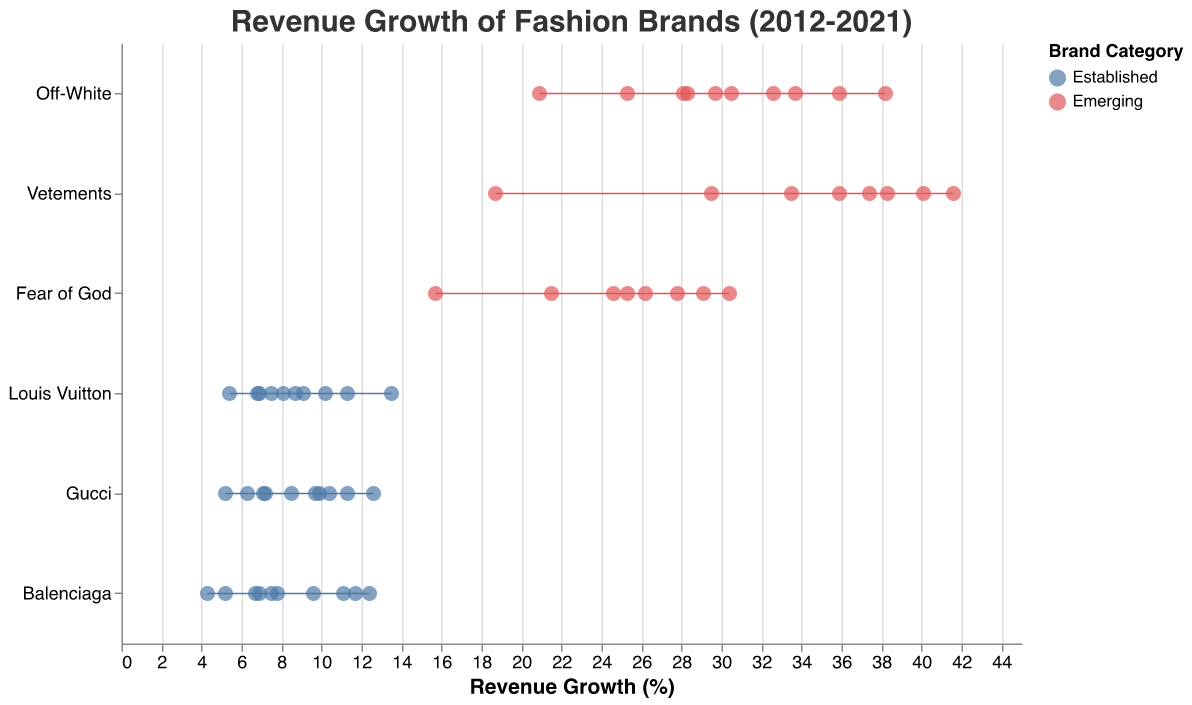What is the title of the figure? The title is usually located at the top of the figure. In this case, it reads "Revenue Growth of Fashion Brands (2012-2021)."
Answer: Revenue Growth of Fashion Brands (2012-2021) Which category has the highest revenue growth rate in any year? By inspecting the plot, we can see that the "Emerging" category, represented in a specific color, has data points reaching up to about 41.6%.
Answer: Emerging How does the revenue growth of Off-White in 2020 compare to 2021? We can find the data points for Off-White in the two years and compare their values. In 2020, it's 20.9%, and in 2021, it's 28.3%.
Answer: 28.3% is higher Which established brand had the lowest revenue growth in 2020? Check the data points for each established brand in 2020. Balenciaga had the lowest revenue growth at 4.3%.
Answer: Balenciaga What is the average revenue growth for Gucci from 2012 to 2021? Adding all the revenue growth percentages of Gucci from 2012 to 2021 and dividing by the number of years: (5.2 + 7.1 + 6.3 + 9.7 + 8.5 + 10.4 + 12.6 + 9.9 + 7.2 + 11.3) / 10 = 8.82
Answer: 8.82% Which brand had the highest revenue growth in 2018? Identify the highest data point for the year 2018. Vetements shows the highest at 41.6%.
Answer: Vetements Compare the revenue growth range between Emerging and Established categories. Look at the range (difference between max and min values) of the revenue growth for both categories. Emerging has a range from 15.7% to 41.6%, while Established ranges from 4.3% to 13.5%.
Answer: Wider for Emerging Which brand had the most consistent revenue growth over the past decade? Consistency can be identified by looking for the smallest fluctuations in growth. Louis Vuitton appears to have the most consistent growth without sharp dips or spikes.
Answer: Louis Vuitton How did Fear of God's revenue growth change from 2019 to 2020? Inspect the data points for Fear of God in 2019 and 2020. It dropped from 29.1% to 15.7%.
Answer: It decreased Which year had the highest revenue growth for established brands? Check the top data points for all established brands across the years. 2021 shows the highest with Louis Vuitton at 13.5%.
Answer: 2021 